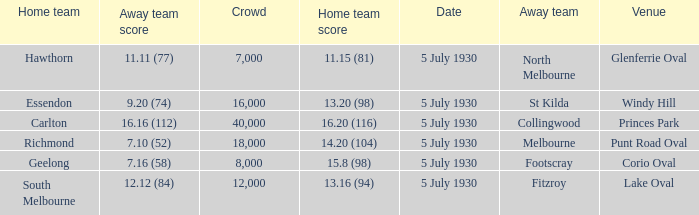What is the venue when fitzroy was the away team? Lake Oval. 